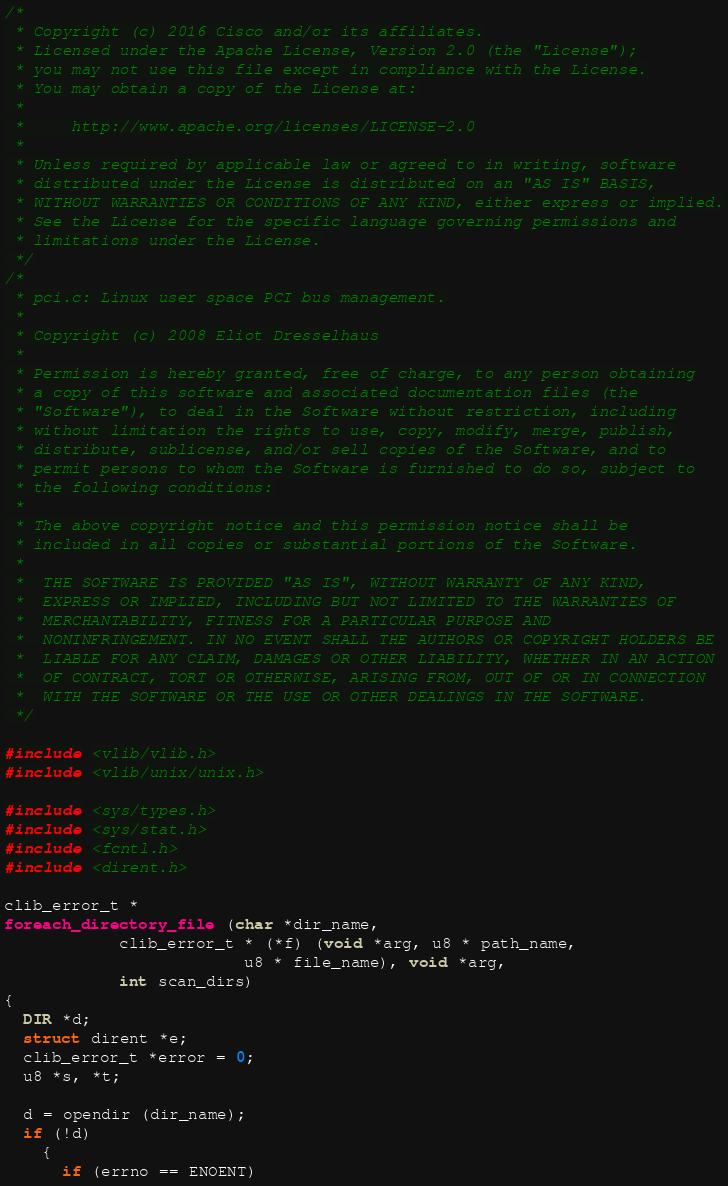Convert code to text. <code><loc_0><loc_0><loc_500><loc_500><_C_>/*
 * Copyright (c) 2016 Cisco and/or its affiliates.
 * Licensed under the Apache License, Version 2.0 (the "License");
 * you may not use this file except in compliance with the License.
 * You may obtain a copy of the License at:
 *
 *     http://www.apache.org/licenses/LICENSE-2.0
 *
 * Unless required by applicable law or agreed to in writing, software
 * distributed under the License is distributed on an "AS IS" BASIS,
 * WITHOUT WARRANTIES OR CONDITIONS OF ANY KIND, either express or implied.
 * See the License for the specific language governing permissions and
 * limitations under the License.
 */
/*
 * pci.c: Linux user space PCI bus management.
 *
 * Copyright (c) 2008 Eliot Dresselhaus
 *
 * Permission is hereby granted, free of charge, to any person obtaining
 * a copy of this software and associated documentation files (the
 * "Software"), to deal in the Software without restriction, including
 * without limitation the rights to use, copy, modify, merge, publish,
 * distribute, sublicense, and/or sell copies of the Software, and to
 * permit persons to whom the Software is furnished to do so, subject to
 * the following conditions:
 *
 * The above copyright notice and this permission notice shall be
 * included in all copies or substantial portions of the Software.
 *
 *  THE SOFTWARE IS PROVIDED "AS IS", WITHOUT WARRANTY OF ANY KIND,
 *  EXPRESS OR IMPLIED, INCLUDING BUT NOT LIMITED TO THE WARRANTIES OF
 *  MERCHANTABILITY, FITNESS FOR A PARTICULAR PURPOSE AND
 *  NONINFRINGEMENT. IN NO EVENT SHALL THE AUTHORS OR COPYRIGHT HOLDERS BE
 *  LIABLE FOR ANY CLAIM, DAMAGES OR OTHER LIABILITY, WHETHER IN AN ACTION
 *  OF CONTRACT, TORT OR OTHERWISE, ARISING FROM, OUT OF OR IN CONNECTION
 *  WITH THE SOFTWARE OR THE USE OR OTHER DEALINGS IN THE SOFTWARE.
 */

#include <vlib/vlib.h>
#include <vlib/unix/unix.h>

#include <sys/types.h>
#include <sys/stat.h>
#include <fcntl.h>
#include <dirent.h>

clib_error_t *
foreach_directory_file (char *dir_name,
			clib_error_t * (*f) (void *arg, u8 * path_name,
					     u8 * file_name), void *arg,
			int scan_dirs)
{
  DIR *d;
  struct dirent *e;
  clib_error_t *error = 0;
  u8 *s, *t;

  d = opendir (dir_name);
  if (!d)
    {
      if (errno == ENOENT)</code> 